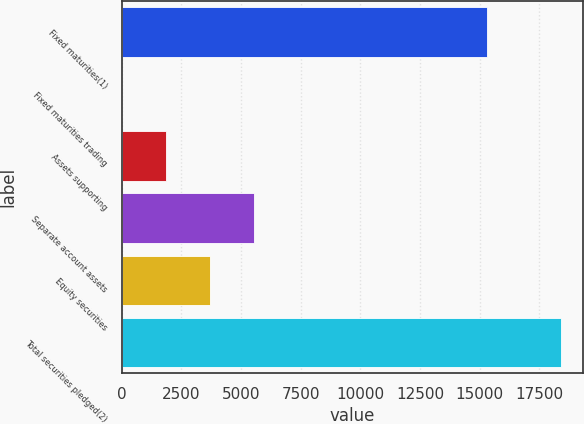Convert chart. <chart><loc_0><loc_0><loc_500><loc_500><bar_chart><fcel>Fixed maturities(1)<fcel>Fixed maturities trading<fcel>Assets supporting<fcel>Separate account assets<fcel>Equity securities<fcel>Total securities pledged(2)<nl><fcel>15319<fcel>1.22<fcel>1841.6<fcel>5522.36<fcel>3681.98<fcel>18405<nl></chart> 